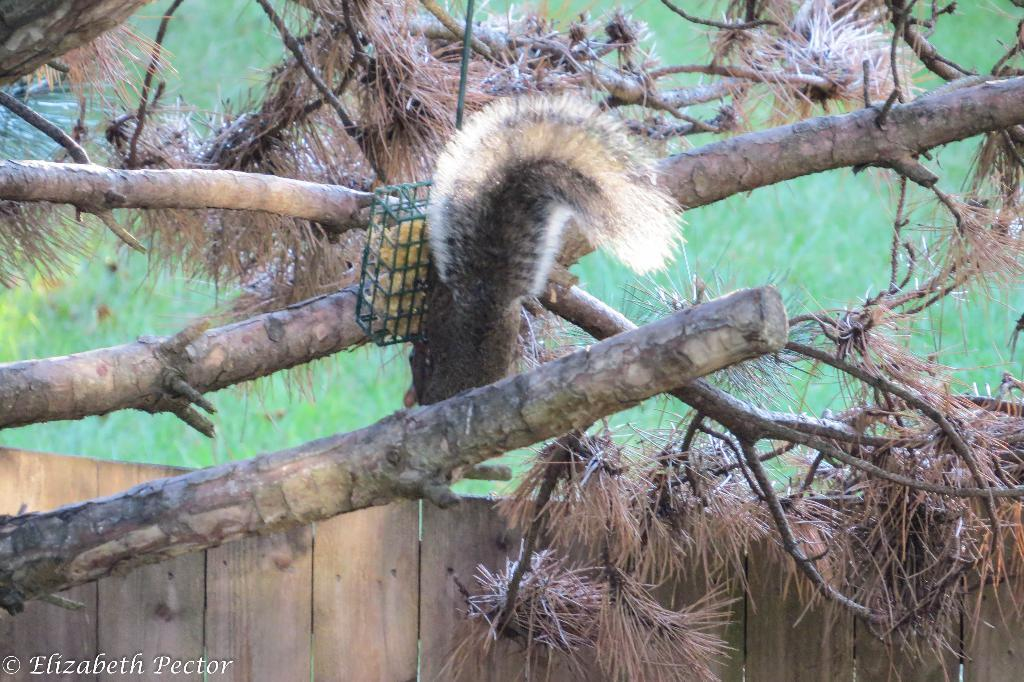What type of animal is in the image? There is a squirrel in the image. Where is the squirrel located? The squirrel is on a tree. What else can be seen in the image besides the squirrel? There are trees, an object attached to a tree, and wooden fencing in the image. What is visible in the background of the image? The background of the image is visible. What grade is the squirrel in the image? The image does not depict a squirrel in a school setting, so it is not possible to determine its grade. 